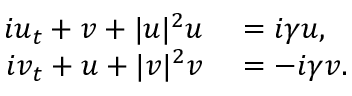Convert formula to latex. <formula><loc_0><loc_0><loc_500><loc_500>\begin{array} { r l } { i u _ { t } + v + | u | ^ { 2 } u } & = i \gamma u , } \\ { i v _ { t } + u + | v | ^ { 2 } v } & = - i \gamma v . } \end{array}</formula> 